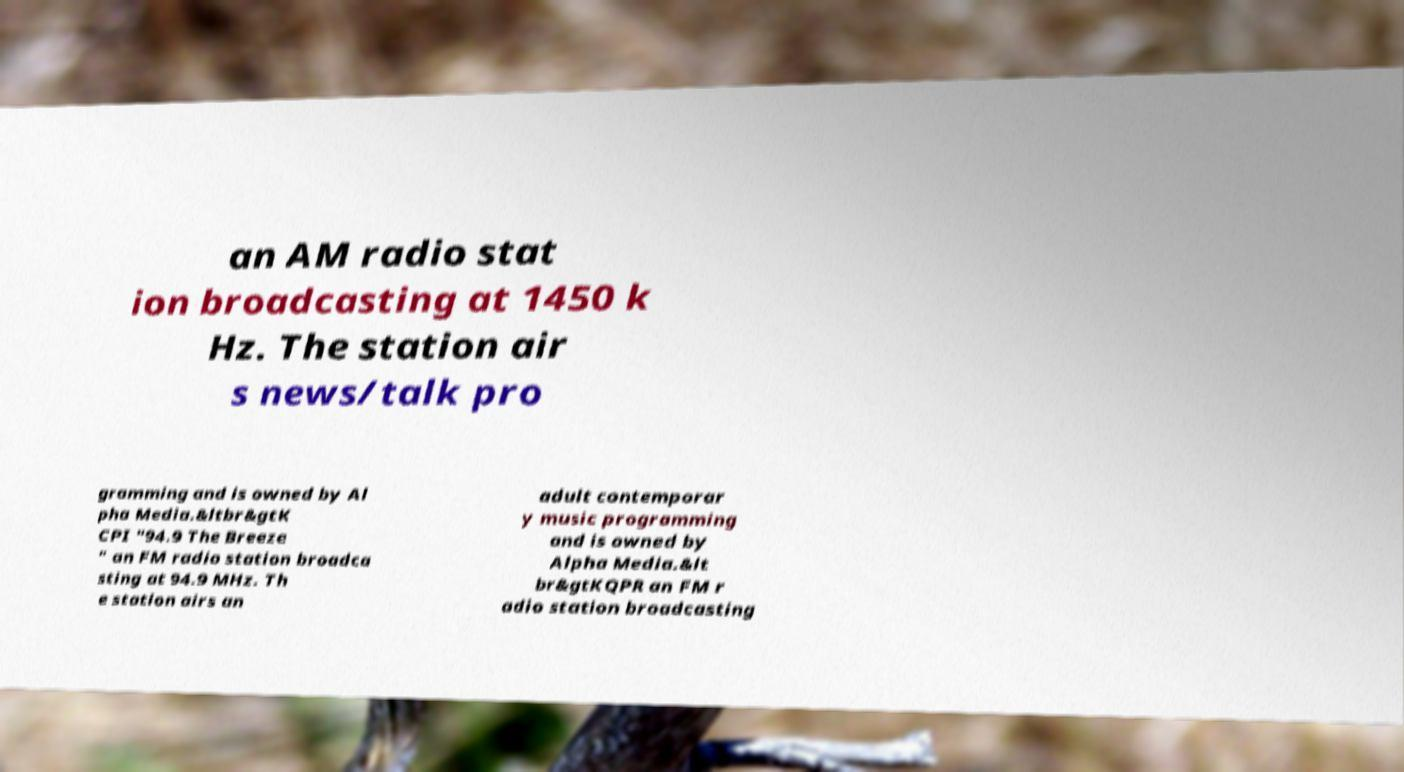Please read and relay the text visible in this image. What does it say? an AM radio stat ion broadcasting at 1450 k Hz. The station air s news/talk pro gramming and is owned by Al pha Media.&ltbr&gtK CPI "94.9 The Breeze " an FM radio station broadca sting at 94.9 MHz. Th e station airs an adult contemporar y music programming and is owned by Alpha Media.&lt br&gtKQPR an FM r adio station broadcasting 